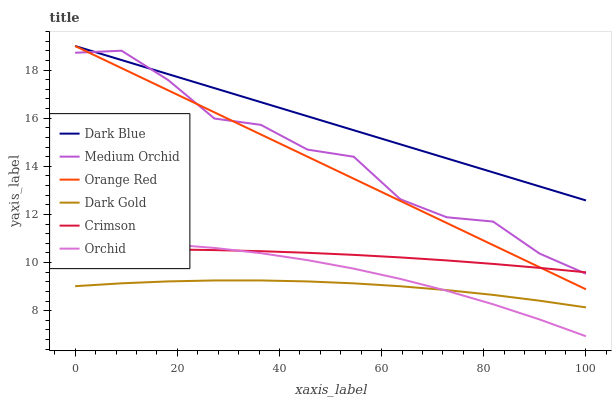Does Medium Orchid have the minimum area under the curve?
Answer yes or no. No. Does Medium Orchid have the maximum area under the curve?
Answer yes or no. No. Is Dark Blue the smoothest?
Answer yes or no. No. Is Dark Blue the roughest?
Answer yes or no. No. Does Medium Orchid have the lowest value?
Answer yes or no. No. Does Medium Orchid have the highest value?
Answer yes or no. No. Is Dark Gold less than Orange Red?
Answer yes or no. Yes. Is Dark Blue greater than Crimson?
Answer yes or no. Yes. Does Dark Gold intersect Orange Red?
Answer yes or no. No. 